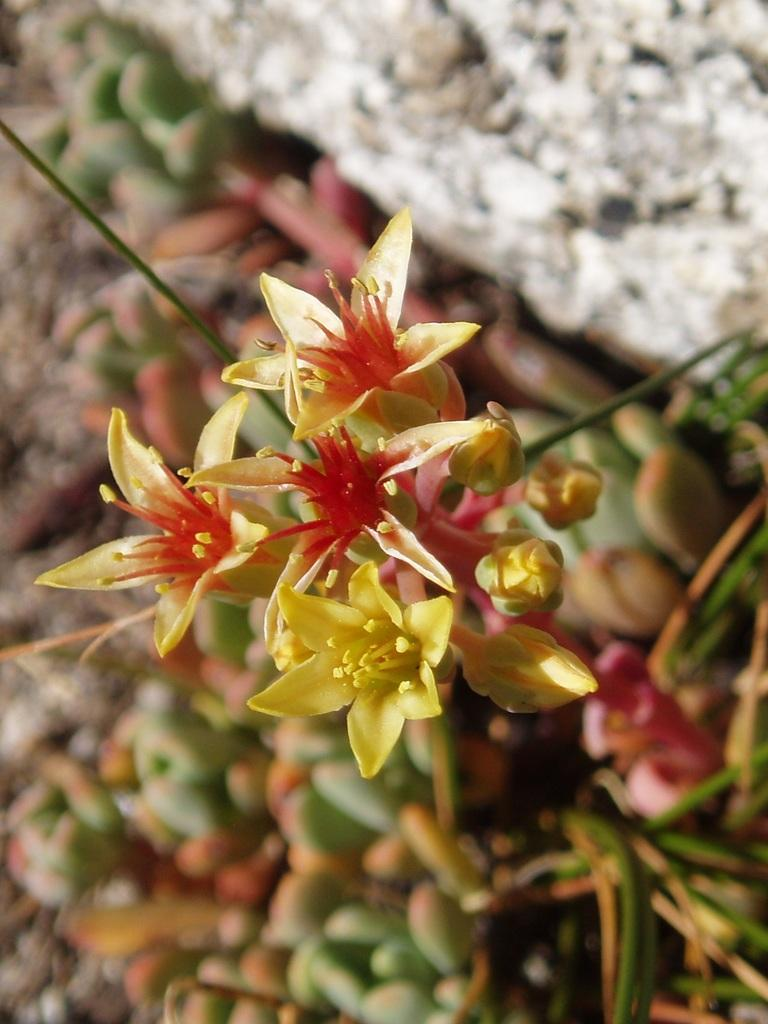What type of plants can be seen in the image? There are flowers in the image. Can you describe the stage of growth for some of the plants? Yes, there are buds in the image. What is located in the top right corner of the image? There is a rock in the top right corner of the image. How would you describe the background of the image? The background of the image is blurred. What advice does the father give to the child in the image? There is no father or child present in the image; it features flowers, buds, a rock, and a blurred background. 